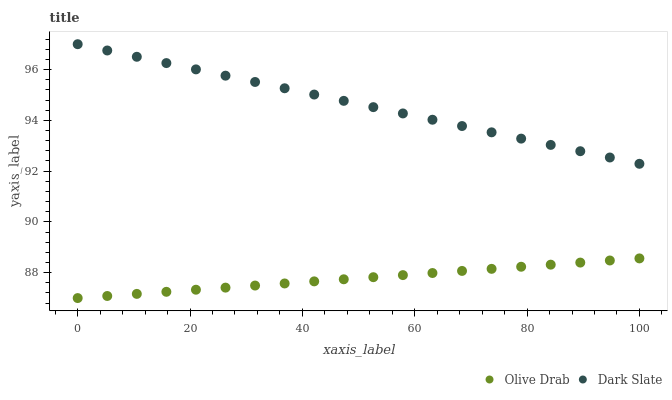Does Olive Drab have the minimum area under the curve?
Answer yes or no. Yes. Does Dark Slate have the maximum area under the curve?
Answer yes or no. Yes. Does Olive Drab have the maximum area under the curve?
Answer yes or no. No. Is Dark Slate the smoothest?
Answer yes or no. Yes. Is Olive Drab the roughest?
Answer yes or no. Yes. Is Olive Drab the smoothest?
Answer yes or no. No. Does Olive Drab have the lowest value?
Answer yes or no. Yes. Does Dark Slate have the highest value?
Answer yes or no. Yes. Does Olive Drab have the highest value?
Answer yes or no. No. Is Olive Drab less than Dark Slate?
Answer yes or no. Yes. Is Dark Slate greater than Olive Drab?
Answer yes or no. Yes. Does Olive Drab intersect Dark Slate?
Answer yes or no. No. 